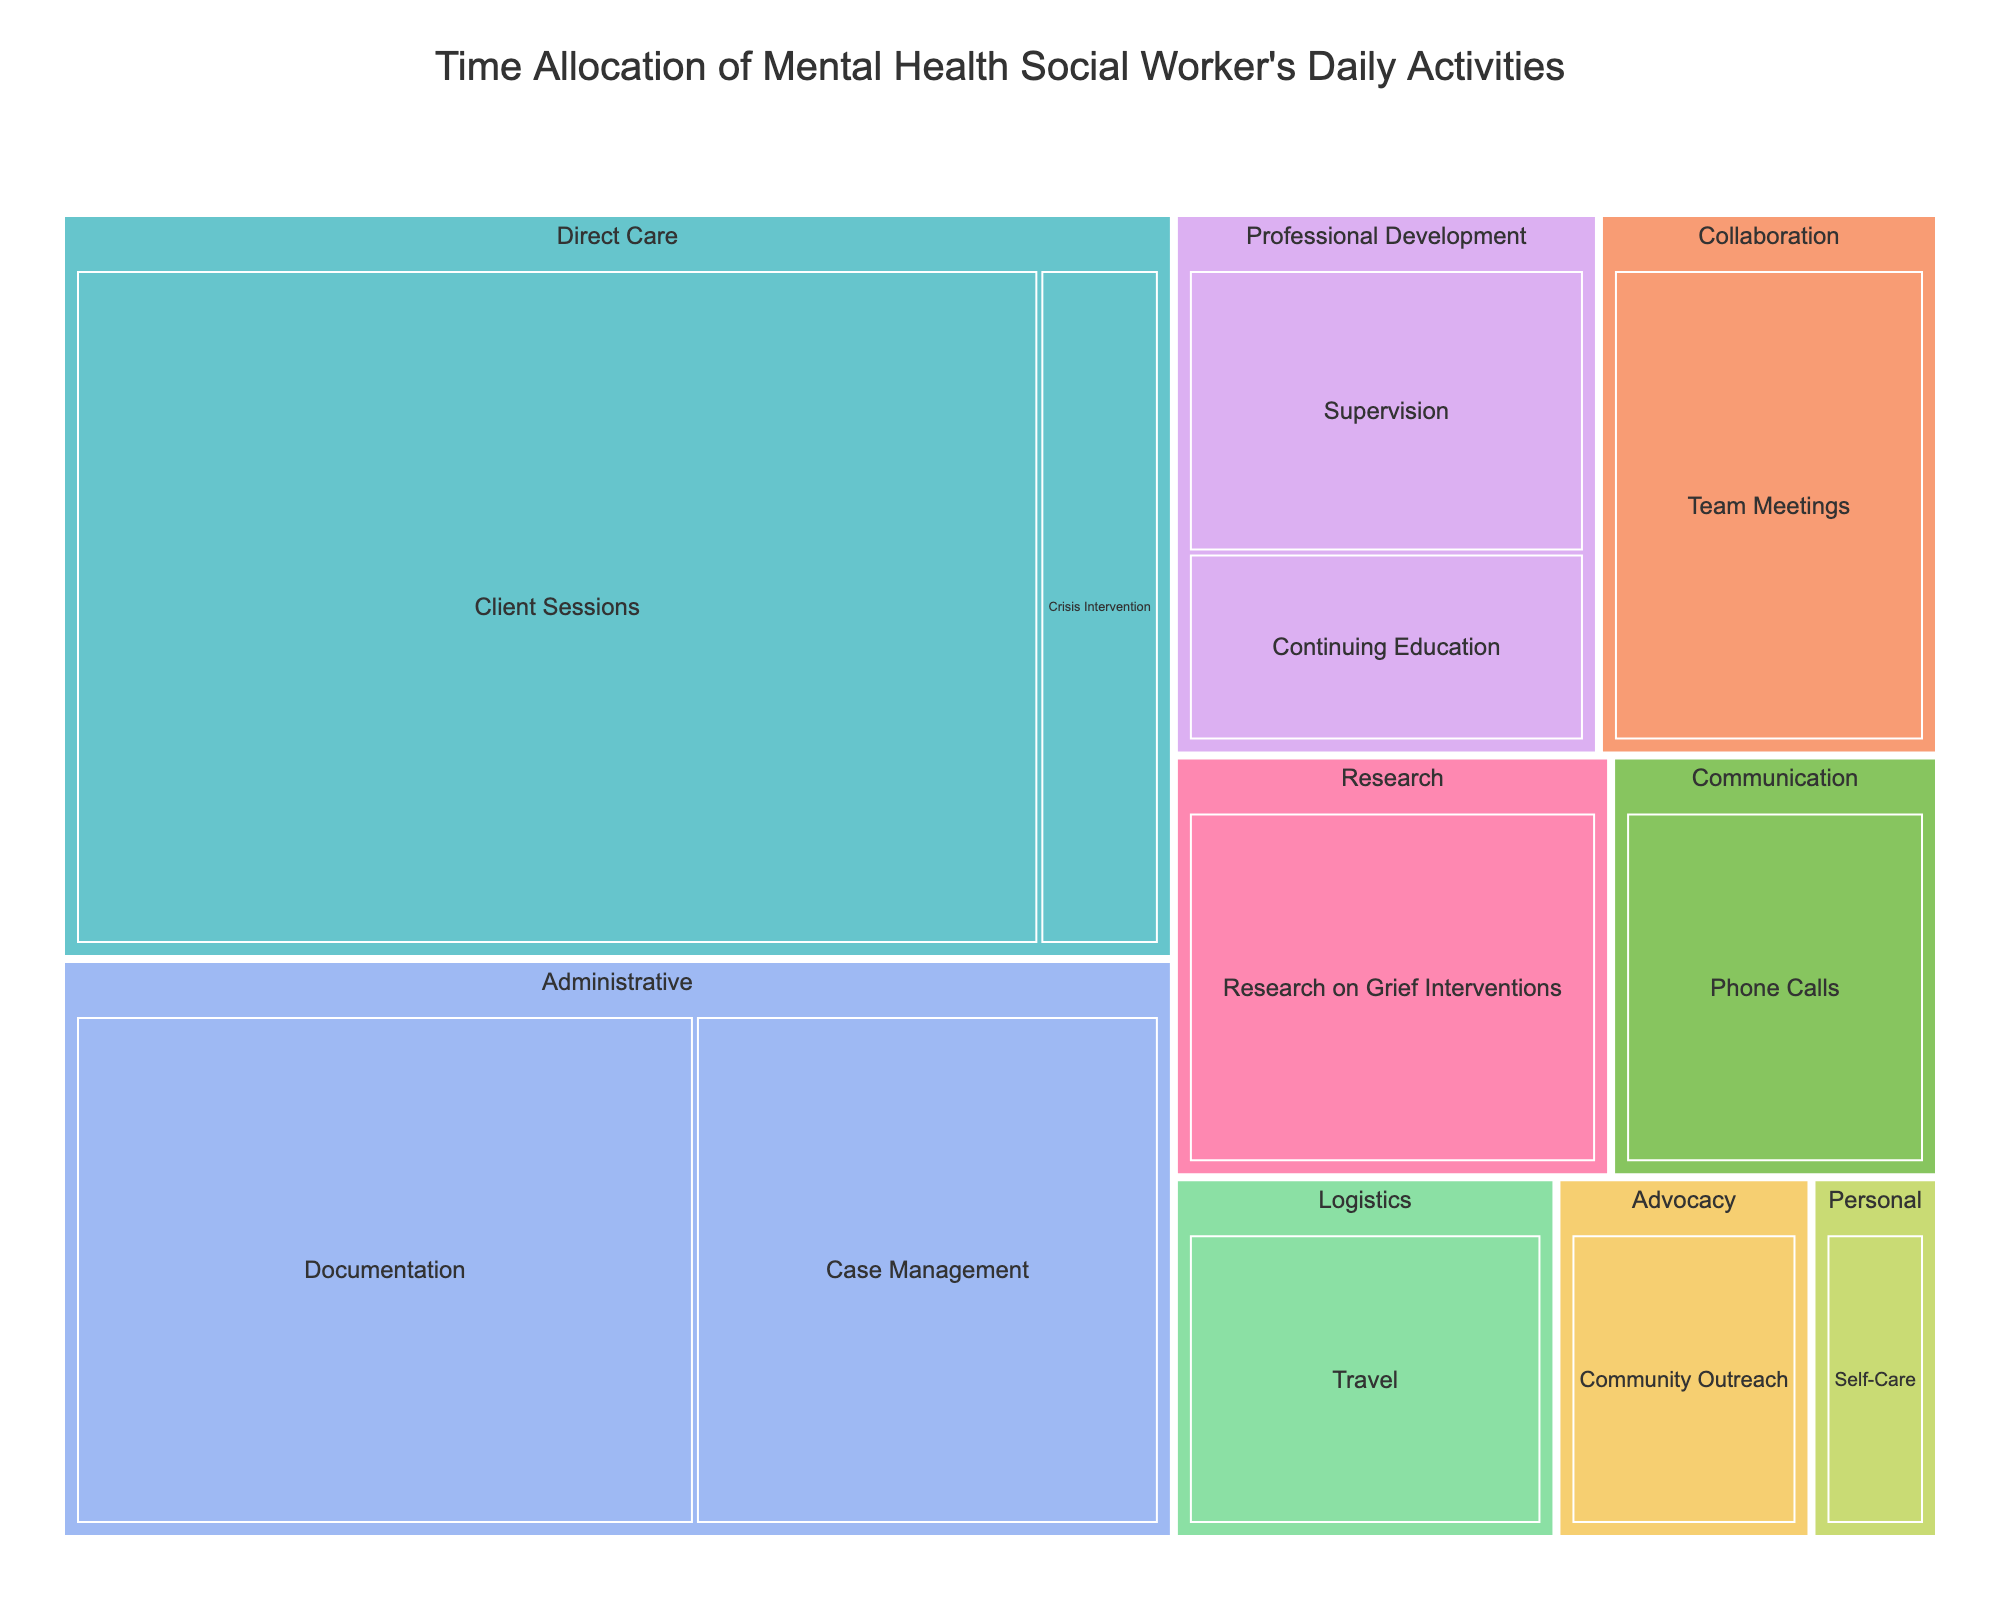What is the title of the treemap? The title of the treemap is usually displayed at the top of the figure. It helps to understand what the figure is about. In this case, it is centered and labeled as 'Time Allocation of Mental Health Social Worker’s Daily Activities'.
Answer: Time Allocation of Mental Health Social Worker’s Daily Activities Which task category has the largest time allocation? To determine the largest time allocation, look for the task category that occupies the most space in the treemap. 'Direct Care' has the largest area.
Answer: Direct Care How much time is spent on Client Sessions? This requires finding the segment in the treemap that represents 'Client Sessions'. It is found under the 'Direct Care' category and shows 240 minutes.
Answer: 240 minutes What's the total time allocated to Administrative tasks? Add the time spent on 'Documentation' and 'Case Management', which are both in the Administrative category: 120 (Documentation) + 90 (Case Management).
Answer: 210 minutes Which category has a higher time allocation: Professional Development or Research? Compare the combined time of tasks under 'Professional Development' (Supervision and Continuing Education) with the time under 'Research' (Research on Grief Interventions). Professional Development is 45 + 30 = 75 minutes, and Research is 60 minutes.
Answer: Professional Development What is the smallest time allocation for any personal task? Identify tasks under the 'Personal' category and find the one with the smallest number. 'Self-Care' is the only task under this category, with 15 minutes.
Answer: 15 minutes How much more time is spent on Team Meetings compared to Crisis Intervention? Subtract the time spent on 'Crisis Intervention' from the time spent on 'Team Meetings'. Team Meetings: 60 minutes, Crisis Intervention: 30 minutes. 60 - 30 = 30 minutes.
Answer: 30 minutes What fraction of the total time is spent on Communication tasks? Find the time spent on 'Phone Calls' under the Communication category and divide by the total time. Phone Calls: 45 minutes. Total time: 240 + 120 + 90 + 60 + 45 + 60 + 45 + 30 + 45 + 30 + 30 + 15 = 810 minutes. Fraction is 45/810.
Answer: 1/18 What tasks are included in the Collaboration category, and how much time is spent on each? Look for the 'Collaboration' category in the treemap and identify the tasks within it: 'Team Meetings' with 60 minutes.
Answer: Team Meetings (60 minutes) Is there more time allocated to Communication or Advocacy? Compare the time spent on 'Phone Calls' under Communication (45 minutes) with the time spent on 'Community Outreach' under Advocacy (30 minutes). Communication has more time allocated.
Answer: Communication 